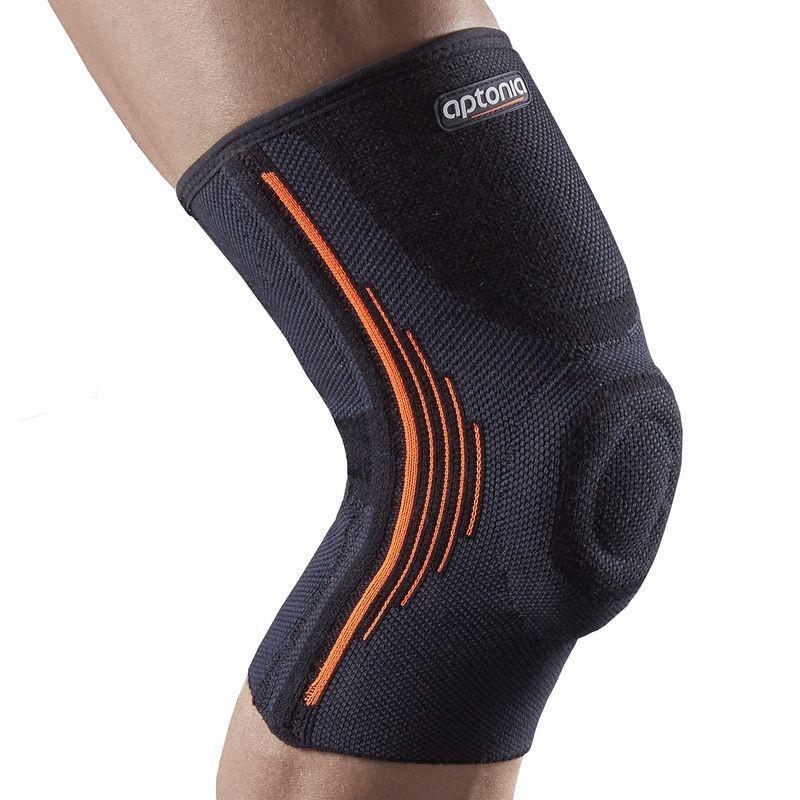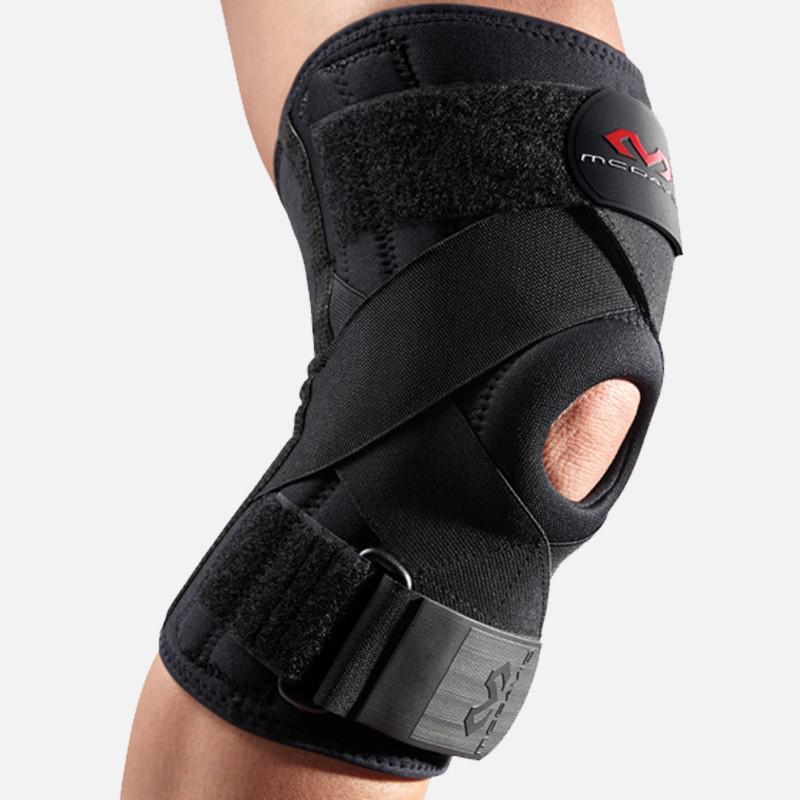The first image is the image on the left, the second image is the image on the right. Given the left and right images, does the statement "At least one of the knee braces is white." hold true? Answer yes or no. No. The first image is the image on the left, the second image is the image on the right. Considering the images on both sides, is "The combined images include two black knee pads worn on bent human knees that face right." valid? Answer yes or no. Yes. 